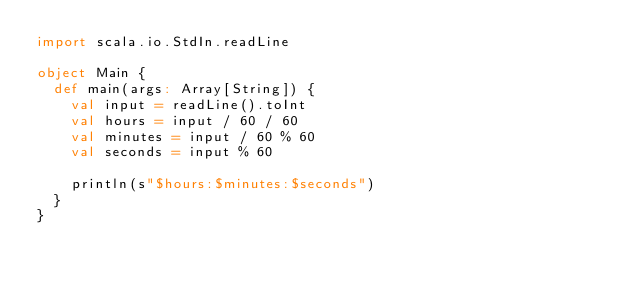Convert code to text. <code><loc_0><loc_0><loc_500><loc_500><_Scala_>import scala.io.StdIn.readLine

object Main {
  def main(args: Array[String]) {
    val input = readLine().toInt
    val hours = input / 60 / 60
    val minutes = input / 60 % 60
    val seconds = input % 60

    println(s"$hours:$minutes:$seconds")
  }
}</code> 